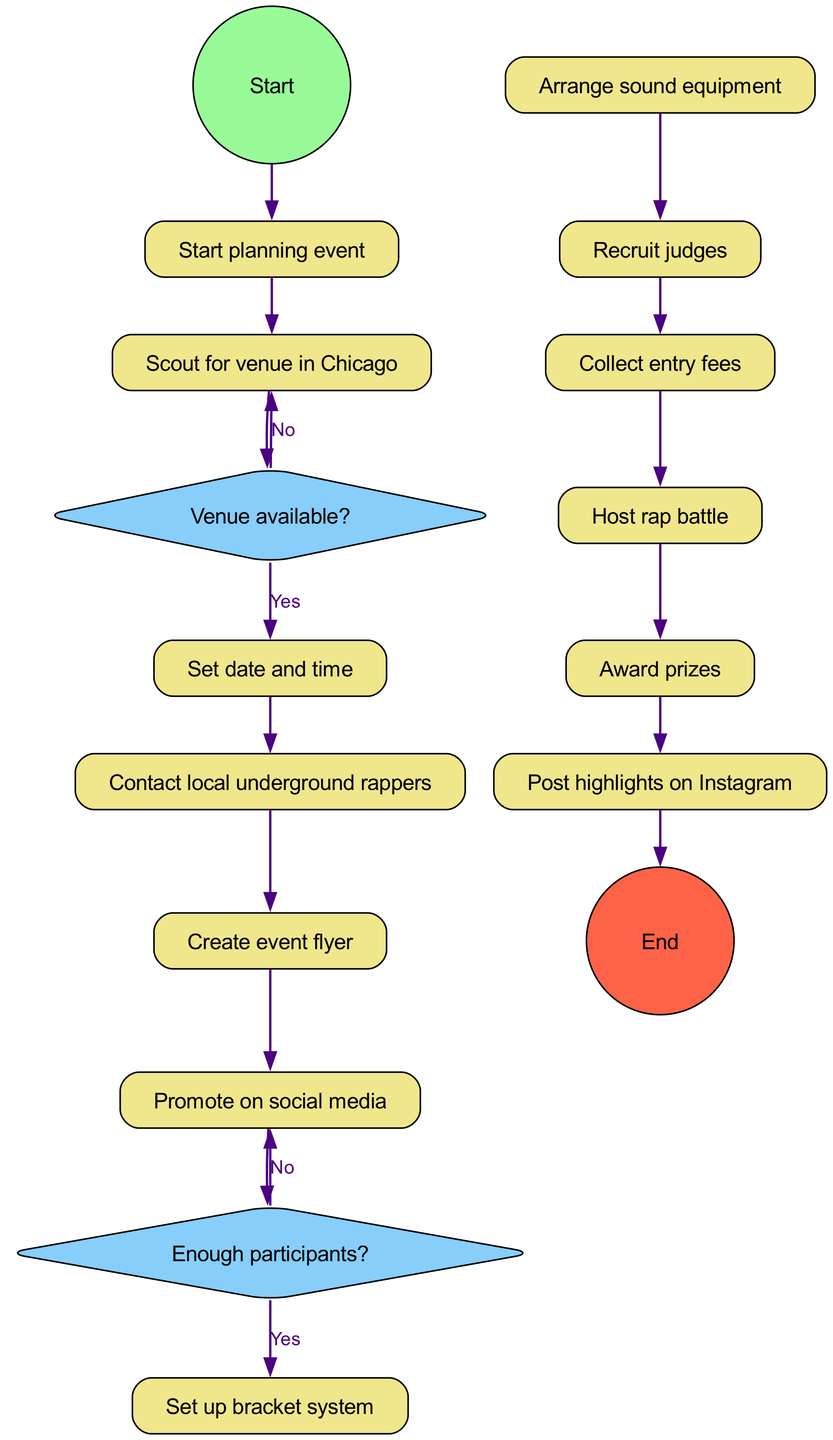What is the first activity in the diagram? The initial node leads directly to the first activity, which is "Scout for venue in Chicago."
Answer: Scout for venue in Chicago How many activities are included in the diagram? There are a total of 12 activities listed under the activities section of the diagram.
Answer: 12 What decision follows the activity "Promote on social media"? After "Promote on social media," the next decision node is "Enough participants?".
Answer: Enough participants? What happens if the venue is not available? If the venue is not available, the flow returns to "Scout for venue in Chicago," indicating that the process will restart at that activity.
Answer: Scout for venue in Chicago What activity comes after "Recruit judges"? Following "Recruit judges," the next activity is "Collect entry fees."
Answer: Collect entry fees How many decisions are present in the diagram? There are 2 decision nodes shown in the diagram, which focus on venue availability and participant numbers.
Answer: 2 What is the final activity before the end of the event? The last activity performed before reaching the end node is "Post highlights on Instagram."
Answer: Post highlights on Instagram What is the relationship between "Set date and time" and "Contact local underground rappers"? "Set date and time" directly follows "Contact local underground rappers," indicating that after confirming the date, the organizer contacts the rappers.
Answer: They are consecutive activities What action is taken if there are not enough participants? If there are not enough participants, the next action is to "Promote on social media" to attract more participants.
Answer: Promote on social media 